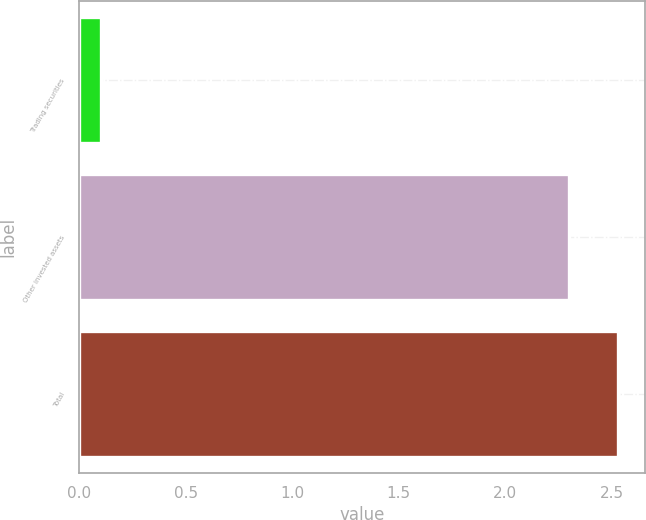<chart> <loc_0><loc_0><loc_500><loc_500><bar_chart><fcel>Trading securities<fcel>Other invested assets<fcel>Total<nl><fcel>0.1<fcel>2.3<fcel>2.53<nl></chart> 